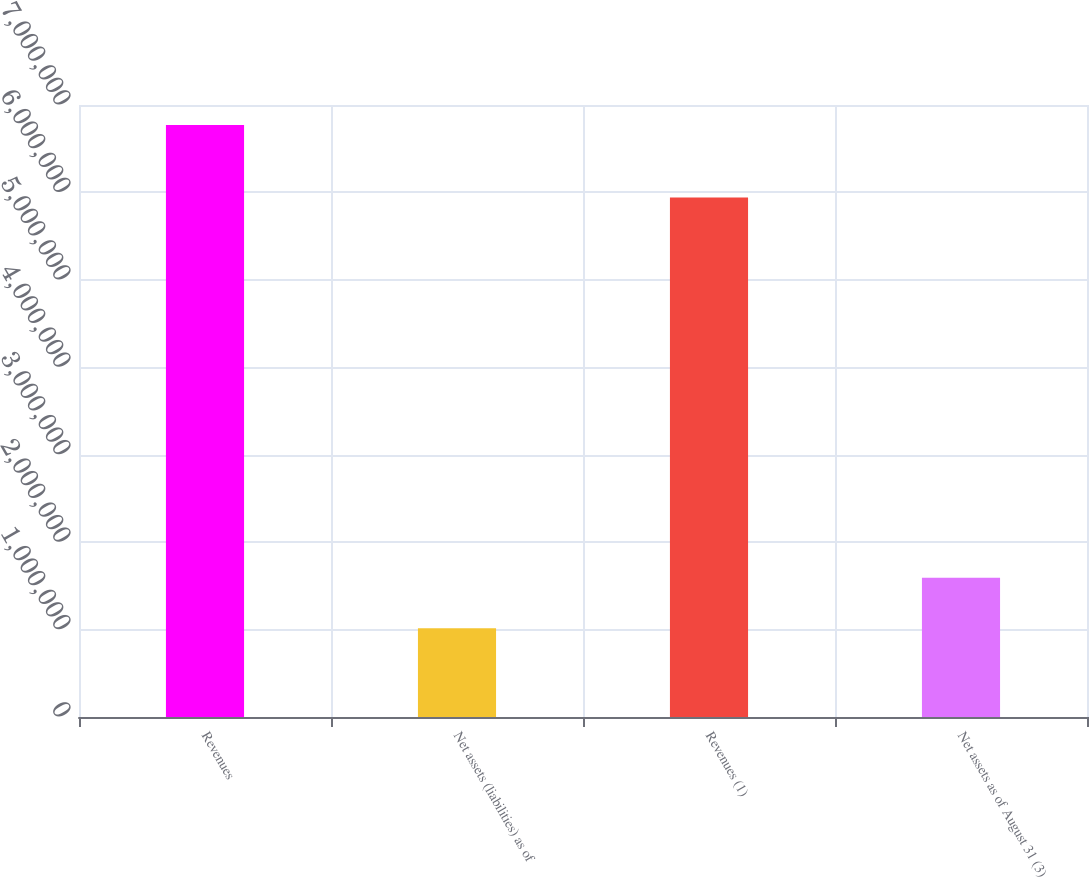Convert chart. <chart><loc_0><loc_0><loc_500><loc_500><bar_chart><fcel>Revenues<fcel>Net assets (liabilities) as of<fcel>Revenues (1)<fcel>Net assets as of August 31 (3)<nl><fcel>6.77198e+06<fcel>1.01602e+06<fcel>5.94201e+06<fcel>1.59161e+06<nl></chart> 